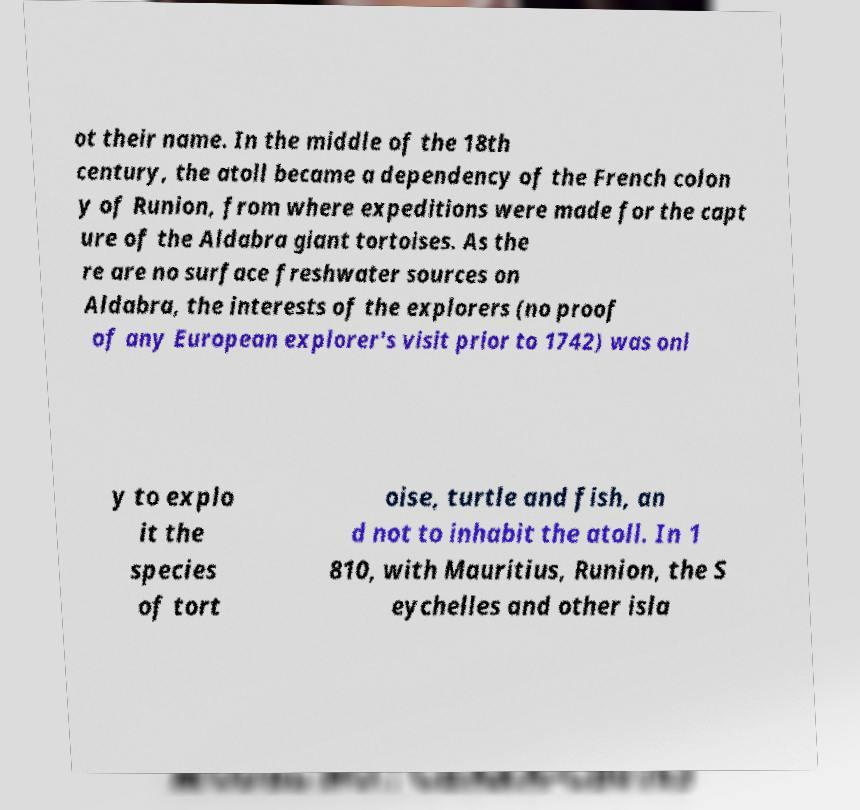Can you accurately transcribe the text from the provided image for me? ot their name. In the middle of the 18th century, the atoll became a dependency of the French colon y of Runion, from where expeditions were made for the capt ure of the Aldabra giant tortoises. As the re are no surface freshwater sources on Aldabra, the interests of the explorers (no proof of any European explorer's visit prior to 1742) was onl y to explo it the species of tort oise, turtle and fish, an d not to inhabit the atoll. In 1 810, with Mauritius, Runion, the S eychelles and other isla 